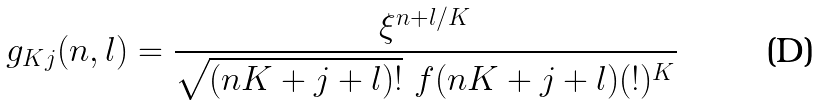Convert formula to latex. <formula><loc_0><loc_0><loc_500><loc_500>g _ { K j } ( n , l ) = \frac { \xi ^ { n + l / K } } { \sqrt { ( n K + j + l ) ! } \text { } f ( n K + j + l ) ( ! ) ^ { K } }</formula> 